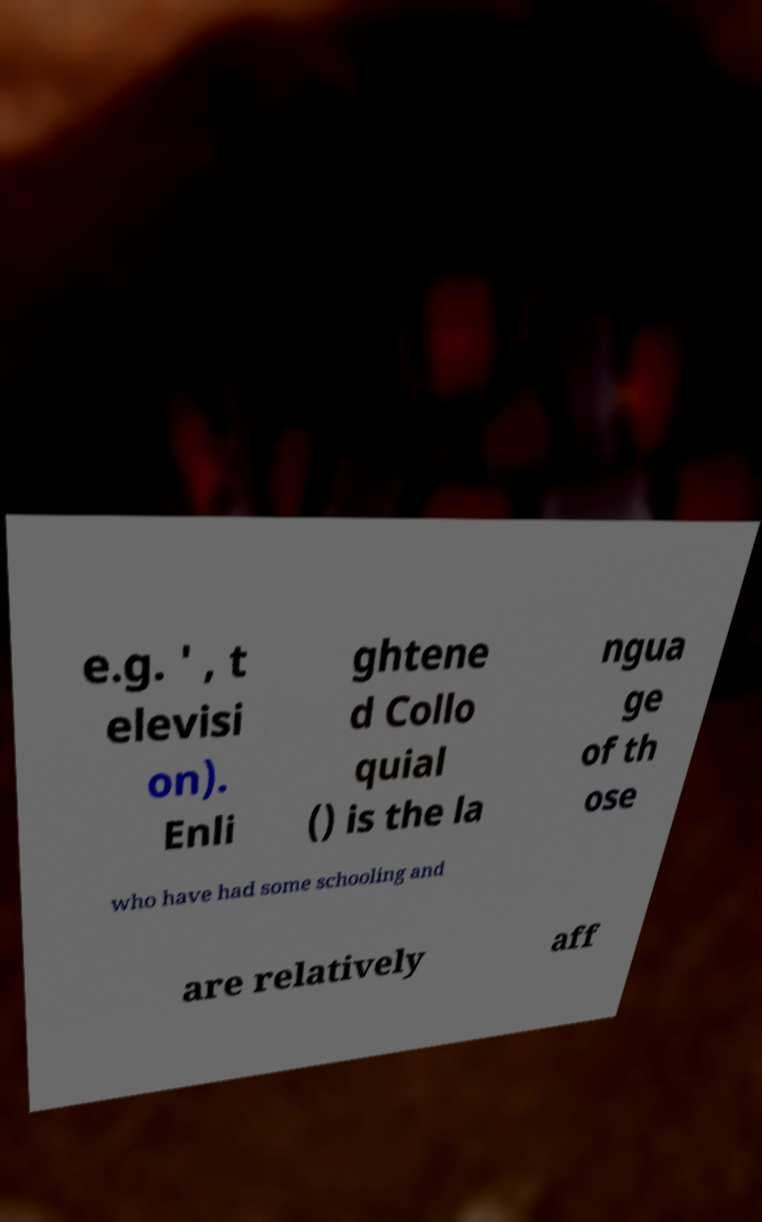For documentation purposes, I need the text within this image transcribed. Could you provide that? e.g. ' , t elevisi on). Enli ghtene d Collo quial () is the la ngua ge of th ose who have had some schooling and are relatively aff 